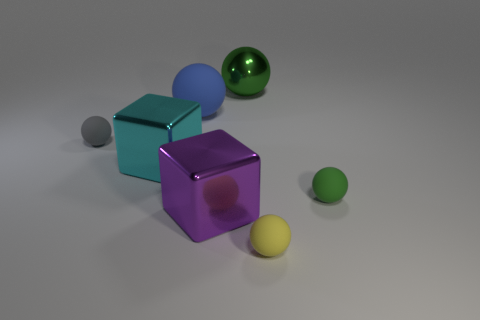There is a gray sphere that is the same size as the yellow matte ball; what material is it? Based on the visual characteristics such as its lack of reflection and the way it diffuses light, the gray sphere appears to be made of a matte material, similar to the yellow ball, which suggests a rubber-like composition. 